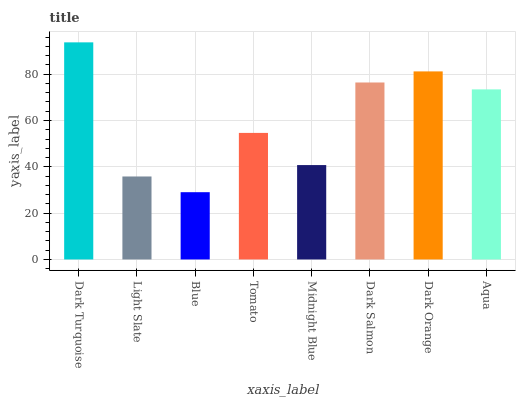Is Blue the minimum?
Answer yes or no. Yes. Is Dark Turquoise the maximum?
Answer yes or no. Yes. Is Light Slate the minimum?
Answer yes or no. No. Is Light Slate the maximum?
Answer yes or no. No. Is Dark Turquoise greater than Light Slate?
Answer yes or no. Yes. Is Light Slate less than Dark Turquoise?
Answer yes or no. Yes. Is Light Slate greater than Dark Turquoise?
Answer yes or no. No. Is Dark Turquoise less than Light Slate?
Answer yes or no. No. Is Aqua the high median?
Answer yes or no. Yes. Is Tomato the low median?
Answer yes or no. Yes. Is Midnight Blue the high median?
Answer yes or no. No. Is Aqua the low median?
Answer yes or no. No. 